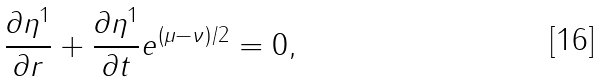<formula> <loc_0><loc_0><loc_500><loc_500>\frac { \partial \eta ^ { 1 } } { \partial r } + \frac { \partial \eta ^ { 1 } } { \partial t } e ^ { ( \mu - \nu ) / 2 } = 0 ,</formula> 